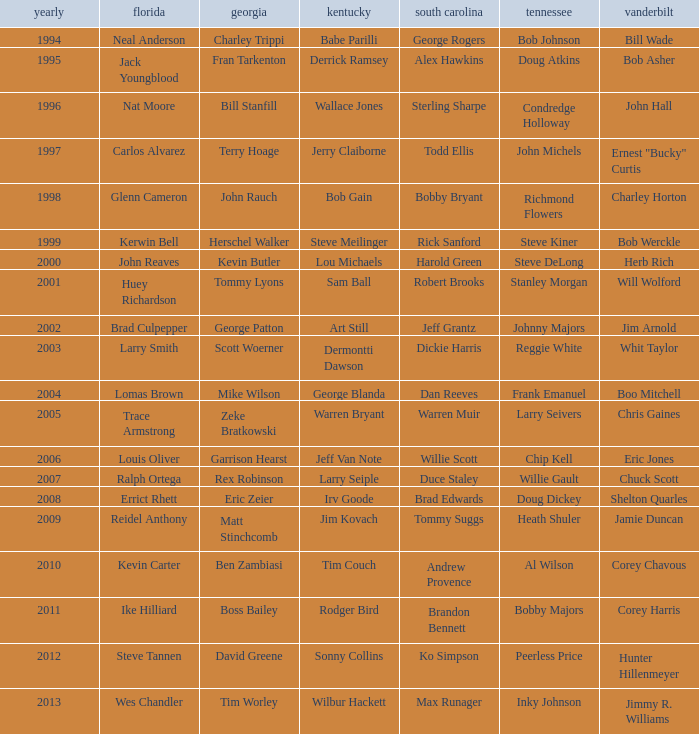What is the Tennessee with a Kentucky of Larry Seiple Willie Gault. Write the full table. {'header': ['yearly', 'florida', 'georgia', 'kentucky', 'south carolina', 'tennessee', 'vanderbilt'], 'rows': [['1994', 'Neal Anderson', 'Charley Trippi', 'Babe Parilli', 'George Rogers', 'Bob Johnson', 'Bill Wade'], ['1995', 'Jack Youngblood', 'Fran Tarkenton', 'Derrick Ramsey', 'Alex Hawkins', 'Doug Atkins', 'Bob Asher'], ['1996', 'Nat Moore', 'Bill Stanfill', 'Wallace Jones', 'Sterling Sharpe', 'Condredge Holloway', 'John Hall'], ['1997', 'Carlos Alvarez', 'Terry Hoage', 'Jerry Claiborne', 'Todd Ellis', 'John Michels', 'Ernest "Bucky" Curtis'], ['1998', 'Glenn Cameron', 'John Rauch', 'Bob Gain', 'Bobby Bryant', 'Richmond Flowers', 'Charley Horton'], ['1999', 'Kerwin Bell', 'Herschel Walker', 'Steve Meilinger', 'Rick Sanford', 'Steve Kiner', 'Bob Werckle'], ['2000', 'John Reaves', 'Kevin Butler', 'Lou Michaels', 'Harold Green', 'Steve DeLong', 'Herb Rich'], ['2001', 'Huey Richardson', 'Tommy Lyons', 'Sam Ball', 'Robert Brooks', 'Stanley Morgan', 'Will Wolford'], ['2002', 'Brad Culpepper', 'George Patton', 'Art Still', 'Jeff Grantz', 'Johnny Majors', 'Jim Arnold'], ['2003', 'Larry Smith', 'Scott Woerner', 'Dermontti Dawson', 'Dickie Harris', 'Reggie White', 'Whit Taylor'], ['2004', 'Lomas Brown', 'Mike Wilson', 'George Blanda', 'Dan Reeves', 'Frank Emanuel', 'Boo Mitchell'], ['2005', 'Trace Armstrong', 'Zeke Bratkowski', 'Warren Bryant', 'Warren Muir', 'Larry Seivers', 'Chris Gaines'], ['2006', 'Louis Oliver', 'Garrison Hearst', 'Jeff Van Note', 'Willie Scott', 'Chip Kell', 'Eric Jones'], ['2007', 'Ralph Ortega', 'Rex Robinson', 'Larry Seiple', 'Duce Staley', 'Willie Gault', 'Chuck Scott'], ['2008', 'Errict Rhett', 'Eric Zeier', 'Irv Goode', 'Brad Edwards', 'Doug Dickey', 'Shelton Quarles'], ['2009', 'Reidel Anthony', 'Matt Stinchcomb', 'Jim Kovach', 'Tommy Suggs', 'Heath Shuler', 'Jamie Duncan'], ['2010', 'Kevin Carter', 'Ben Zambiasi', 'Tim Couch', 'Andrew Provence', 'Al Wilson', 'Corey Chavous'], ['2011', 'Ike Hilliard', 'Boss Bailey', 'Rodger Bird', 'Brandon Bennett', 'Bobby Majors', 'Corey Harris'], ['2012', 'Steve Tannen', 'David Greene', 'Sonny Collins', 'Ko Simpson', 'Peerless Price', 'Hunter Hillenmeyer'], ['2013', 'Wes Chandler', 'Tim Worley', 'Wilbur Hackett', 'Max Runager', 'Inky Johnson', 'Jimmy R. Williams']]} 